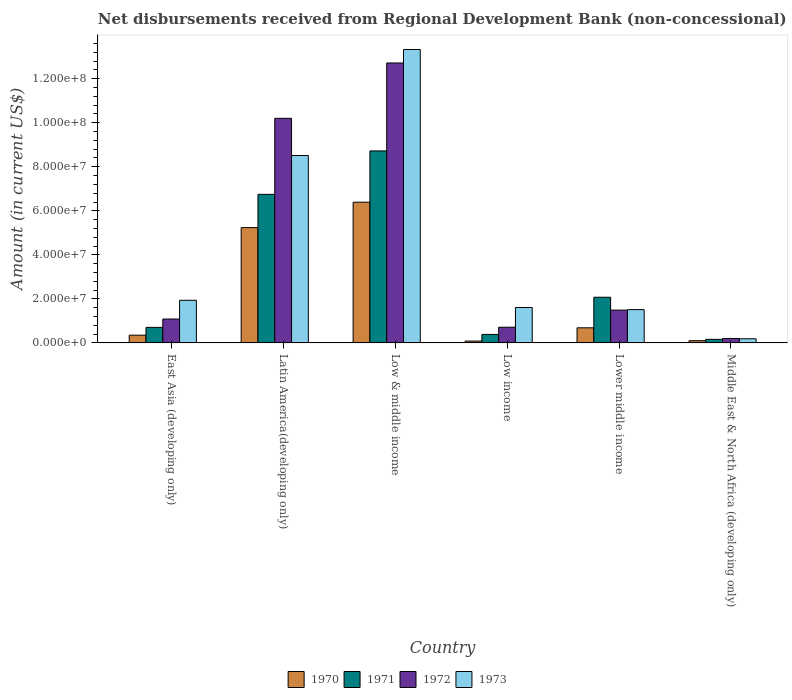How many groups of bars are there?
Your answer should be compact. 6. Are the number of bars per tick equal to the number of legend labels?
Provide a succinct answer. Yes. Are the number of bars on each tick of the X-axis equal?
Keep it short and to the point. Yes. How many bars are there on the 6th tick from the left?
Keep it short and to the point. 4. How many bars are there on the 1st tick from the right?
Give a very brief answer. 4. What is the label of the 1st group of bars from the left?
Provide a succinct answer. East Asia (developing only). What is the amount of disbursements received from Regional Development Bank in 1970 in East Asia (developing only)?
Provide a short and direct response. 3.53e+06. Across all countries, what is the maximum amount of disbursements received from Regional Development Bank in 1972?
Give a very brief answer. 1.27e+08. Across all countries, what is the minimum amount of disbursements received from Regional Development Bank in 1970?
Keep it short and to the point. 8.50e+05. What is the total amount of disbursements received from Regional Development Bank in 1970 in the graph?
Your answer should be compact. 1.29e+08. What is the difference between the amount of disbursements received from Regional Development Bank in 1970 in Low & middle income and that in Lower middle income?
Provide a short and direct response. 5.70e+07. What is the difference between the amount of disbursements received from Regional Development Bank in 1970 in Low & middle income and the amount of disbursements received from Regional Development Bank in 1971 in East Asia (developing only)?
Provide a short and direct response. 5.68e+07. What is the average amount of disbursements received from Regional Development Bank in 1971 per country?
Your answer should be very brief. 3.13e+07. What is the difference between the amount of disbursements received from Regional Development Bank of/in 1972 and amount of disbursements received from Regional Development Bank of/in 1971 in East Asia (developing only)?
Keep it short and to the point. 3.80e+06. What is the ratio of the amount of disbursements received from Regional Development Bank in 1971 in Latin America(developing only) to that in Low & middle income?
Provide a succinct answer. 0.77. What is the difference between the highest and the second highest amount of disbursements received from Regional Development Bank in 1973?
Your answer should be compact. 1.14e+08. What is the difference between the highest and the lowest amount of disbursements received from Regional Development Bank in 1973?
Your answer should be very brief. 1.31e+08. Is the sum of the amount of disbursements received from Regional Development Bank in 1971 in Latin America(developing only) and Low & middle income greater than the maximum amount of disbursements received from Regional Development Bank in 1972 across all countries?
Provide a succinct answer. Yes. Is it the case that in every country, the sum of the amount of disbursements received from Regional Development Bank in 1971 and amount of disbursements received from Regional Development Bank in 1972 is greater than the sum of amount of disbursements received from Regional Development Bank in 1973 and amount of disbursements received from Regional Development Bank in 1970?
Provide a short and direct response. No. What does the 2nd bar from the right in Low & middle income represents?
Provide a short and direct response. 1972. Is it the case that in every country, the sum of the amount of disbursements received from Regional Development Bank in 1972 and amount of disbursements received from Regional Development Bank in 1971 is greater than the amount of disbursements received from Regional Development Bank in 1970?
Offer a terse response. Yes. Are all the bars in the graph horizontal?
Your response must be concise. No. What is the difference between two consecutive major ticks on the Y-axis?
Your answer should be compact. 2.00e+07. Does the graph contain any zero values?
Give a very brief answer. No. How many legend labels are there?
Offer a very short reply. 4. What is the title of the graph?
Ensure brevity in your answer.  Net disbursements received from Regional Development Bank (non-concessional). What is the label or title of the X-axis?
Your answer should be compact. Country. What is the label or title of the Y-axis?
Your answer should be compact. Amount (in current US$). What is the Amount (in current US$) of 1970 in East Asia (developing only)?
Offer a terse response. 3.53e+06. What is the Amount (in current US$) in 1971 in East Asia (developing only)?
Your response must be concise. 7.06e+06. What is the Amount (in current US$) of 1972 in East Asia (developing only)?
Provide a succinct answer. 1.09e+07. What is the Amount (in current US$) of 1973 in East Asia (developing only)?
Offer a terse response. 1.94e+07. What is the Amount (in current US$) of 1970 in Latin America(developing only)?
Offer a terse response. 5.24e+07. What is the Amount (in current US$) of 1971 in Latin America(developing only)?
Ensure brevity in your answer.  6.75e+07. What is the Amount (in current US$) in 1972 in Latin America(developing only)?
Make the answer very short. 1.02e+08. What is the Amount (in current US$) in 1973 in Latin America(developing only)?
Provide a succinct answer. 8.51e+07. What is the Amount (in current US$) in 1970 in Low & middle income?
Keep it short and to the point. 6.39e+07. What is the Amount (in current US$) in 1971 in Low & middle income?
Your answer should be compact. 8.72e+07. What is the Amount (in current US$) in 1972 in Low & middle income?
Offer a terse response. 1.27e+08. What is the Amount (in current US$) of 1973 in Low & middle income?
Offer a very short reply. 1.33e+08. What is the Amount (in current US$) of 1970 in Low income?
Provide a succinct answer. 8.50e+05. What is the Amount (in current US$) in 1971 in Low income?
Your response must be concise. 3.88e+06. What is the Amount (in current US$) in 1972 in Low income?
Offer a terse response. 7.14e+06. What is the Amount (in current US$) of 1973 in Low income?
Your answer should be very brief. 1.61e+07. What is the Amount (in current US$) in 1970 in Lower middle income?
Offer a very short reply. 6.87e+06. What is the Amount (in current US$) in 1971 in Lower middle income?
Keep it short and to the point. 2.08e+07. What is the Amount (in current US$) of 1972 in Lower middle income?
Your answer should be compact. 1.49e+07. What is the Amount (in current US$) in 1973 in Lower middle income?
Your answer should be compact. 1.51e+07. What is the Amount (in current US$) in 1970 in Middle East & North Africa (developing only)?
Provide a succinct answer. 1.02e+06. What is the Amount (in current US$) of 1971 in Middle East & North Africa (developing only)?
Ensure brevity in your answer.  1.64e+06. What is the Amount (in current US$) in 1972 in Middle East & North Africa (developing only)?
Your response must be concise. 2.02e+06. What is the Amount (in current US$) of 1973 in Middle East & North Africa (developing only)?
Keep it short and to the point. 1.90e+06. Across all countries, what is the maximum Amount (in current US$) of 1970?
Provide a succinct answer. 6.39e+07. Across all countries, what is the maximum Amount (in current US$) in 1971?
Provide a short and direct response. 8.72e+07. Across all countries, what is the maximum Amount (in current US$) of 1972?
Offer a terse response. 1.27e+08. Across all countries, what is the maximum Amount (in current US$) in 1973?
Offer a terse response. 1.33e+08. Across all countries, what is the minimum Amount (in current US$) in 1970?
Give a very brief answer. 8.50e+05. Across all countries, what is the minimum Amount (in current US$) of 1971?
Provide a short and direct response. 1.64e+06. Across all countries, what is the minimum Amount (in current US$) of 1972?
Make the answer very short. 2.02e+06. Across all countries, what is the minimum Amount (in current US$) in 1973?
Make the answer very short. 1.90e+06. What is the total Amount (in current US$) of 1970 in the graph?
Offer a terse response. 1.29e+08. What is the total Amount (in current US$) in 1971 in the graph?
Make the answer very short. 1.88e+08. What is the total Amount (in current US$) in 1972 in the graph?
Your answer should be very brief. 2.64e+08. What is the total Amount (in current US$) in 1973 in the graph?
Ensure brevity in your answer.  2.71e+08. What is the difference between the Amount (in current US$) in 1970 in East Asia (developing only) and that in Latin America(developing only)?
Give a very brief answer. -4.88e+07. What is the difference between the Amount (in current US$) of 1971 in East Asia (developing only) and that in Latin America(developing only)?
Your response must be concise. -6.04e+07. What is the difference between the Amount (in current US$) of 1972 in East Asia (developing only) and that in Latin America(developing only)?
Your answer should be compact. -9.11e+07. What is the difference between the Amount (in current US$) of 1973 in East Asia (developing only) and that in Latin America(developing only)?
Your answer should be very brief. -6.58e+07. What is the difference between the Amount (in current US$) of 1970 in East Asia (developing only) and that in Low & middle income?
Your answer should be very brief. -6.04e+07. What is the difference between the Amount (in current US$) in 1971 in East Asia (developing only) and that in Low & middle income?
Provide a short and direct response. -8.01e+07. What is the difference between the Amount (in current US$) in 1972 in East Asia (developing only) and that in Low & middle income?
Offer a terse response. -1.16e+08. What is the difference between the Amount (in current US$) in 1973 in East Asia (developing only) and that in Low & middle income?
Provide a short and direct response. -1.14e+08. What is the difference between the Amount (in current US$) in 1970 in East Asia (developing only) and that in Low income?
Offer a terse response. 2.68e+06. What is the difference between the Amount (in current US$) of 1971 in East Asia (developing only) and that in Low income?
Make the answer very short. 3.19e+06. What is the difference between the Amount (in current US$) of 1972 in East Asia (developing only) and that in Low income?
Offer a terse response. 3.72e+06. What is the difference between the Amount (in current US$) of 1973 in East Asia (developing only) and that in Low income?
Your answer should be compact. 3.28e+06. What is the difference between the Amount (in current US$) in 1970 in East Asia (developing only) and that in Lower middle income?
Your answer should be very brief. -3.34e+06. What is the difference between the Amount (in current US$) of 1971 in East Asia (developing only) and that in Lower middle income?
Make the answer very short. -1.37e+07. What is the difference between the Amount (in current US$) in 1972 in East Asia (developing only) and that in Lower middle income?
Your response must be concise. -4.04e+06. What is the difference between the Amount (in current US$) in 1973 in East Asia (developing only) and that in Lower middle income?
Provide a succinct answer. 4.23e+06. What is the difference between the Amount (in current US$) of 1970 in East Asia (developing only) and that in Middle East & North Africa (developing only)?
Provide a short and direct response. 2.51e+06. What is the difference between the Amount (in current US$) in 1971 in East Asia (developing only) and that in Middle East & North Africa (developing only)?
Keep it short and to the point. 5.43e+06. What is the difference between the Amount (in current US$) of 1972 in East Asia (developing only) and that in Middle East & North Africa (developing only)?
Provide a short and direct response. 8.83e+06. What is the difference between the Amount (in current US$) of 1973 in East Asia (developing only) and that in Middle East & North Africa (developing only)?
Offer a very short reply. 1.75e+07. What is the difference between the Amount (in current US$) in 1970 in Latin America(developing only) and that in Low & middle income?
Offer a very short reply. -1.15e+07. What is the difference between the Amount (in current US$) of 1971 in Latin America(developing only) and that in Low & middle income?
Your answer should be compact. -1.97e+07. What is the difference between the Amount (in current US$) of 1972 in Latin America(developing only) and that in Low & middle income?
Keep it short and to the point. -2.51e+07. What is the difference between the Amount (in current US$) in 1973 in Latin America(developing only) and that in Low & middle income?
Make the answer very short. -4.81e+07. What is the difference between the Amount (in current US$) in 1970 in Latin America(developing only) and that in Low income?
Provide a short and direct response. 5.15e+07. What is the difference between the Amount (in current US$) of 1971 in Latin America(developing only) and that in Low income?
Make the answer very short. 6.36e+07. What is the difference between the Amount (in current US$) of 1972 in Latin America(developing only) and that in Low income?
Provide a short and direct response. 9.49e+07. What is the difference between the Amount (in current US$) of 1973 in Latin America(developing only) and that in Low income?
Your answer should be compact. 6.90e+07. What is the difference between the Amount (in current US$) of 1970 in Latin America(developing only) and that in Lower middle income?
Keep it short and to the point. 4.55e+07. What is the difference between the Amount (in current US$) in 1971 in Latin America(developing only) and that in Lower middle income?
Give a very brief answer. 4.67e+07. What is the difference between the Amount (in current US$) in 1972 in Latin America(developing only) and that in Lower middle income?
Offer a terse response. 8.71e+07. What is the difference between the Amount (in current US$) of 1973 in Latin America(developing only) and that in Lower middle income?
Offer a very short reply. 7.00e+07. What is the difference between the Amount (in current US$) in 1970 in Latin America(developing only) and that in Middle East & North Africa (developing only)?
Provide a succinct answer. 5.14e+07. What is the difference between the Amount (in current US$) of 1971 in Latin America(developing only) and that in Middle East & North Africa (developing only)?
Your answer should be very brief. 6.58e+07. What is the difference between the Amount (in current US$) of 1972 in Latin America(developing only) and that in Middle East & North Africa (developing only)?
Your response must be concise. 1.00e+08. What is the difference between the Amount (in current US$) of 1973 in Latin America(developing only) and that in Middle East & North Africa (developing only)?
Make the answer very short. 8.32e+07. What is the difference between the Amount (in current US$) of 1970 in Low & middle income and that in Low income?
Your response must be concise. 6.31e+07. What is the difference between the Amount (in current US$) of 1971 in Low & middle income and that in Low income?
Provide a succinct answer. 8.33e+07. What is the difference between the Amount (in current US$) of 1972 in Low & middle income and that in Low income?
Give a very brief answer. 1.20e+08. What is the difference between the Amount (in current US$) in 1973 in Low & middle income and that in Low income?
Your answer should be compact. 1.17e+08. What is the difference between the Amount (in current US$) of 1970 in Low & middle income and that in Lower middle income?
Your answer should be very brief. 5.70e+07. What is the difference between the Amount (in current US$) of 1971 in Low & middle income and that in Lower middle income?
Give a very brief answer. 6.64e+07. What is the difference between the Amount (in current US$) of 1972 in Low & middle income and that in Lower middle income?
Ensure brevity in your answer.  1.12e+08. What is the difference between the Amount (in current US$) in 1973 in Low & middle income and that in Lower middle income?
Provide a short and direct response. 1.18e+08. What is the difference between the Amount (in current US$) in 1970 in Low & middle income and that in Middle East & North Africa (developing only)?
Ensure brevity in your answer.  6.29e+07. What is the difference between the Amount (in current US$) of 1971 in Low & middle income and that in Middle East & North Africa (developing only)?
Keep it short and to the point. 8.56e+07. What is the difference between the Amount (in current US$) in 1972 in Low & middle income and that in Middle East & North Africa (developing only)?
Provide a succinct answer. 1.25e+08. What is the difference between the Amount (in current US$) of 1973 in Low & middle income and that in Middle East & North Africa (developing only)?
Keep it short and to the point. 1.31e+08. What is the difference between the Amount (in current US$) in 1970 in Low income and that in Lower middle income?
Provide a short and direct response. -6.02e+06. What is the difference between the Amount (in current US$) of 1971 in Low income and that in Lower middle income?
Provide a succinct answer. -1.69e+07. What is the difference between the Amount (in current US$) in 1972 in Low income and that in Lower middle income?
Offer a very short reply. -7.76e+06. What is the difference between the Amount (in current US$) in 1973 in Low income and that in Lower middle income?
Offer a very short reply. 9.55e+05. What is the difference between the Amount (in current US$) in 1970 in Low income and that in Middle East & North Africa (developing only)?
Your answer should be very brief. -1.71e+05. What is the difference between the Amount (in current US$) in 1971 in Low income and that in Middle East & North Africa (developing only)?
Offer a terse response. 2.24e+06. What is the difference between the Amount (in current US$) of 1972 in Low income and that in Middle East & North Africa (developing only)?
Your response must be concise. 5.11e+06. What is the difference between the Amount (in current US$) in 1973 in Low income and that in Middle East & North Africa (developing only)?
Provide a short and direct response. 1.42e+07. What is the difference between the Amount (in current US$) of 1970 in Lower middle income and that in Middle East & North Africa (developing only)?
Provide a short and direct response. 5.85e+06. What is the difference between the Amount (in current US$) of 1971 in Lower middle income and that in Middle East & North Africa (developing only)?
Provide a short and direct response. 1.91e+07. What is the difference between the Amount (in current US$) in 1972 in Lower middle income and that in Middle East & North Africa (developing only)?
Ensure brevity in your answer.  1.29e+07. What is the difference between the Amount (in current US$) of 1973 in Lower middle income and that in Middle East & North Africa (developing only)?
Offer a very short reply. 1.32e+07. What is the difference between the Amount (in current US$) of 1970 in East Asia (developing only) and the Amount (in current US$) of 1971 in Latin America(developing only)?
Keep it short and to the point. -6.39e+07. What is the difference between the Amount (in current US$) in 1970 in East Asia (developing only) and the Amount (in current US$) in 1972 in Latin America(developing only)?
Ensure brevity in your answer.  -9.85e+07. What is the difference between the Amount (in current US$) in 1970 in East Asia (developing only) and the Amount (in current US$) in 1973 in Latin America(developing only)?
Keep it short and to the point. -8.16e+07. What is the difference between the Amount (in current US$) of 1971 in East Asia (developing only) and the Amount (in current US$) of 1972 in Latin America(developing only)?
Give a very brief answer. -9.49e+07. What is the difference between the Amount (in current US$) of 1971 in East Asia (developing only) and the Amount (in current US$) of 1973 in Latin America(developing only)?
Offer a terse response. -7.81e+07. What is the difference between the Amount (in current US$) in 1972 in East Asia (developing only) and the Amount (in current US$) in 1973 in Latin America(developing only)?
Offer a very short reply. -7.43e+07. What is the difference between the Amount (in current US$) in 1970 in East Asia (developing only) and the Amount (in current US$) in 1971 in Low & middle income?
Provide a succinct answer. -8.37e+07. What is the difference between the Amount (in current US$) of 1970 in East Asia (developing only) and the Amount (in current US$) of 1972 in Low & middle income?
Ensure brevity in your answer.  -1.24e+08. What is the difference between the Amount (in current US$) in 1970 in East Asia (developing only) and the Amount (in current US$) in 1973 in Low & middle income?
Keep it short and to the point. -1.30e+08. What is the difference between the Amount (in current US$) in 1971 in East Asia (developing only) and the Amount (in current US$) in 1972 in Low & middle income?
Provide a short and direct response. -1.20e+08. What is the difference between the Amount (in current US$) of 1971 in East Asia (developing only) and the Amount (in current US$) of 1973 in Low & middle income?
Your answer should be compact. -1.26e+08. What is the difference between the Amount (in current US$) in 1972 in East Asia (developing only) and the Amount (in current US$) in 1973 in Low & middle income?
Offer a terse response. -1.22e+08. What is the difference between the Amount (in current US$) of 1970 in East Asia (developing only) and the Amount (in current US$) of 1971 in Low income?
Provide a short and direct response. -3.48e+05. What is the difference between the Amount (in current US$) of 1970 in East Asia (developing only) and the Amount (in current US$) of 1972 in Low income?
Provide a succinct answer. -3.61e+06. What is the difference between the Amount (in current US$) in 1970 in East Asia (developing only) and the Amount (in current US$) in 1973 in Low income?
Your answer should be compact. -1.26e+07. What is the difference between the Amount (in current US$) of 1971 in East Asia (developing only) and the Amount (in current US$) of 1972 in Low income?
Your answer should be very brief. -7.50e+04. What is the difference between the Amount (in current US$) in 1971 in East Asia (developing only) and the Amount (in current US$) in 1973 in Low income?
Your answer should be very brief. -9.03e+06. What is the difference between the Amount (in current US$) in 1972 in East Asia (developing only) and the Amount (in current US$) in 1973 in Low income?
Offer a very short reply. -5.23e+06. What is the difference between the Amount (in current US$) of 1970 in East Asia (developing only) and the Amount (in current US$) of 1971 in Lower middle income?
Provide a short and direct response. -1.72e+07. What is the difference between the Amount (in current US$) in 1970 in East Asia (developing only) and the Amount (in current US$) in 1972 in Lower middle income?
Keep it short and to the point. -1.14e+07. What is the difference between the Amount (in current US$) in 1970 in East Asia (developing only) and the Amount (in current US$) in 1973 in Lower middle income?
Keep it short and to the point. -1.16e+07. What is the difference between the Amount (in current US$) of 1971 in East Asia (developing only) and the Amount (in current US$) of 1972 in Lower middle income?
Keep it short and to the point. -7.84e+06. What is the difference between the Amount (in current US$) of 1971 in East Asia (developing only) and the Amount (in current US$) of 1973 in Lower middle income?
Ensure brevity in your answer.  -8.07e+06. What is the difference between the Amount (in current US$) in 1972 in East Asia (developing only) and the Amount (in current US$) in 1973 in Lower middle income?
Your answer should be very brief. -4.28e+06. What is the difference between the Amount (in current US$) of 1970 in East Asia (developing only) and the Amount (in current US$) of 1971 in Middle East & North Africa (developing only)?
Your response must be concise. 1.89e+06. What is the difference between the Amount (in current US$) in 1970 in East Asia (developing only) and the Amount (in current US$) in 1972 in Middle East & North Africa (developing only)?
Provide a short and direct response. 1.50e+06. What is the difference between the Amount (in current US$) of 1970 in East Asia (developing only) and the Amount (in current US$) of 1973 in Middle East & North Africa (developing only)?
Your answer should be very brief. 1.63e+06. What is the difference between the Amount (in current US$) of 1971 in East Asia (developing only) and the Amount (in current US$) of 1972 in Middle East & North Africa (developing only)?
Your response must be concise. 5.04e+06. What is the difference between the Amount (in current US$) of 1971 in East Asia (developing only) and the Amount (in current US$) of 1973 in Middle East & North Africa (developing only)?
Offer a terse response. 5.17e+06. What is the difference between the Amount (in current US$) of 1972 in East Asia (developing only) and the Amount (in current US$) of 1973 in Middle East & North Africa (developing only)?
Ensure brevity in your answer.  8.96e+06. What is the difference between the Amount (in current US$) in 1970 in Latin America(developing only) and the Amount (in current US$) in 1971 in Low & middle income?
Provide a short and direct response. -3.48e+07. What is the difference between the Amount (in current US$) in 1970 in Latin America(developing only) and the Amount (in current US$) in 1972 in Low & middle income?
Provide a short and direct response. -7.48e+07. What is the difference between the Amount (in current US$) of 1970 in Latin America(developing only) and the Amount (in current US$) of 1973 in Low & middle income?
Provide a short and direct response. -8.09e+07. What is the difference between the Amount (in current US$) in 1971 in Latin America(developing only) and the Amount (in current US$) in 1972 in Low & middle income?
Ensure brevity in your answer.  -5.97e+07. What is the difference between the Amount (in current US$) of 1971 in Latin America(developing only) and the Amount (in current US$) of 1973 in Low & middle income?
Ensure brevity in your answer.  -6.58e+07. What is the difference between the Amount (in current US$) of 1972 in Latin America(developing only) and the Amount (in current US$) of 1973 in Low & middle income?
Your answer should be compact. -3.12e+07. What is the difference between the Amount (in current US$) of 1970 in Latin America(developing only) and the Amount (in current US$) of 1971 in Low income?
Provide a short and direct response. 4.85e+07. What is the difference between the Amount (in current US$) in 1970 in Latin America(developing only) and the Amount (in current US$) in 1972 in Low income?
Offer a terse response. 4.52e+07. What is the difference between the Amount (in current US$) of 1970 in Latin America(developing only) and the Amount (in current US$) of 1973 in Low income?
Offer a very short reply. 3.63e+07. What is the difference between the Amount (in current US$) in 1971 in Latin America(developing only) and the Amount (in current US$) in 1972 in Low income?
Give a very brief answer. 6.03e+07. What is the difference between the Amount (in current US$) in 1971 in Latin America(developing only) and the Amount (in current US$) in 1973 in Low income?
Keep it short and to the point. 5.14e+07. What is the difference between the Amount (in current US$) in 1972 in Latin America(developing only) and the Amount (in current US$) in 1973 in Low income?
Offer a very short reply. 8.59e+07. What is the difference between the Amount (in current US$) in 1970 in Latin America(developing only) and the Amount (in current US$) in 1971 in Lower middle income?
Provide a short and direct response. 3.16e+07. What is the difference between the Amount (in current US$) of 1970 in Latin America(developing only) and the Amount (in current US$) of 1972 in Lower middle income?
Your answer should be very brief. 3.75e+07. What is the difference between the Amount (in current US$) of 1970 in Latin America(developing only) and the Amount (in current US$) of 1973 in Lower middle income?
Give a very brief answer. 3.72e+07. What is the difference between the Amount (in current US$) of 1971 in Latin America(developing only) and the Amount (in current US$) of 1972 in Lower middle income?
Give a very brief answer. 5.26e+07. What is the difference between the Amount (in current US$) of 1971 in Latin America(developing only) and the Amount (in current US$) of 1973 in Lower middle income?
Offer a terse response. 5.23e+07. What is the difference between the Amount (in current US$) of 1972 in Latin America(developing only) and the Amount (in current US$) of 1973 in Lower middle income?
Keep it short and to the point. 8.69e+07. What is the difference between the Amount (in current US$) in 1970 in Latin America(developing only) and the Amount (in current US$) in 1971 in Middle East & North Africa (developing only)?
Make the answer very short. 5.07e+07. What is the difference between the Amount (in current US$) of 1970 in Latin America(developing only) and the Amount (in current US$) of 1972 in Middle East & North Africa (developing only)?
Provide a short and direct response. 5.04e+07. What is the difference between the Amount (in current US$) in 1970 in Latin America(developing only) and the Amount (in current US$) in 1973 in Middle East & North Africa (developing only)?
Make the answer very short. 5.05e+07. What is the difference between the Amount (in current US$) in 1971 in Latin America(developing only) and the Amount (in current US$) in 1972 in Middle East & North Africa (developing only)?
Provide a succinct answer. 6.55e+07. What is the difference between the Amount (in current US$) of 1971 in Latin America(developing only) and the Amount (in current US$) of 1973 in Middle East & North Africa (developing only)?
Make the answer very short. 6.56e+07. What is the difference between the Amount (in current US$) in 1972 in Latin America(developing only) and the Amount (in current US$) in 1973 in Middle East & North Africa (developing only)?
Make the answer very short. 1.00e+08. What is the difference between the Amount (in current US$) of 1970 in Low & middle income and the Amount (in current US$) of 1971 in Low income?
Provide a succinct answer. 6.00e+07. What is the difference between the Amount (in current US$) of 1970 in Low & middle income and the Amount (in current US$) of 1972 in Low income?
Ensure brevity in your answer.  5.68e+07. What is the difference between the Amount (in current US$) in 1970 in Low & middle income and the Amount (in current US$) in 1973 in Low income?
Provide a succinct answer. 4.78e+07. What is the difference between the Amount (in current US$) of 1971 in Low & middle income and the Amount (in current US$) of 1972 in Low income?
Offer a very short reply. 8.01e+07. What is the difference between the Amount (in current US$) of 1971 in Low & middle income and the Amount (in current US$) of 1973 in Low income?
Give a very brief answer. 7.11e+07. What is the difference between the Amount (in current US$) of 1972 in Low & middle income and the Amount (in current US$) of 1973 in Low income?
Offer a terse response. 1.11e+08. What is the difference between the Amount (in current US$) of 1970 in Low & middle income and the Amount (in current US$) of 1971 in Lower middle income?
Your response must be concise. 4.32e+07. What is the difference between the Amount (in current US$) of 1970 in Low & middle income and the Amount (in current US$) of 1972 in Lower middle income?
Keep it short and to the point. 4.90e+07. What is the difference between the Amount (in current US$) in 1970 in Low & middle income and the Amount (in current US$) in 1973 in Lower middle income?
Provide a short and direct response. 4.88e+07. What is the difference between the Amount (in current US$) of 1971 in Low & middle income and the Amount (in current US$) of 1972 in Lower middle income?
Your answer should be very brief. 7.23e+07. What is the difference between the Amount (in current US$) of 1971 in Low & middle income and the Amount (in current US$) of 1973 in Lower middle income?
Ensure brevity in your answer.  7.21e+07. What is the difference between the Amount (in current US$) in 1972 in Low & middle income and the Amount (in current US$) in 1973 in Lower middle income?
Give a very brief answer. 1.12e+08. What is the difference between the Amount (in current US$) in 1970 in Low & middle income and the Amount (in current US$) in 1971 in Middle East & North Africa (developing only)?
Your response must be concise. 6.23e+07. What is the difference between the Amount (in current US$) of 1970 in Low & middle income and the Amount (in current US$) of 1972 in Middle East & North Africa (developing only)?
Your response must be concise. 6.19e+07. What is the difference between the Amount (in current US$) of 1970 in Low & middle income and the Amount (in current US$) of 1973 in Middle East & North Africa (developing only)?
Provide a succinct answer. 6.20e+07. What is the difference between the Amount (in current US$) in 1971 in Low & middle income and the Amount (in current US$) in 1972 in Middle East & North Africa (developing only)?
Ensure brevity in your answer.  8.52e+07. What is the difference between the Amount (in current US$) in 1971 in Low & middle income and the Amount (in current US$) in 1973 in Middle East & North Africa (developing only)?
Give a very brief answer. 8.53e+07. What is the difference between the Amount (in current US$) in 1972 in Low & middle income and the Amount (in current US$) in 1973 in Middle East & North Africa (developing only)?
Your response must be concise. 1.25e+08. What is the difference between the Amount (in current US$) in 1970 in Low income and the Amount (in current US$) in 1971 in Lower middle income?
Keep it short and to the point. -1.99e+07. What is the difference between the Amount (in current US$) of 1970 in Low income and the Amount (in current US$) of 1972 in Lower middle income?
Give a very brief answer. -1.40e+07. What is the difference between the Amount (in current US$) of 1970 in Low income and the Amount (in current US$) of 1973 in Lower middle income?
Make the answer very short. -1.43e+07. What is the difference between the Amount (in current US$) of 1971 in Low income and the Amount (in current US$) of 1972 in Lower middle income?
Offer a terse response. -1.10e+07. What is the difference between the Amount (in current US$) in 1971 in Low income and the Amount (in current US$) in 1973 in Lower middle income?
Keep it short and to the point. -1.13e+07. What is the difference between the Amount (in current US$) of 1972 in Low income and the Amount (in current US$) of 1973 in Lower middle income?
Provide a succinct answer. -8.00e+06. What is the difference between the Amount (in current US$) in 1970 in Low income and the Amount (in current US$) in 1971 in Middle East & North Africa (developing only)?
Provide a succinct answer. -7.85e+05. What is the difference between the Amount (in current US$) in 1970 in Low income and the Amount (in current US$) in 1972 in Middle East & North Africa (developing only)?
Your answer should be compact. -1.17e+06. What is the difference between the Amount (in current US$) in 1970 in Low income and the Amount (in current US$) in 1973 in Middle East & North Africa (developing only)?
Your response must be concise. -1.05e+06. What is the difference between the Amount (in current US$) in 1971 in Low income and the Amount (in current US$) in 1972 in Middle East & North Africa (developing only)?
Your answer should be compact. 1.85e+06. What is the difference between the Amount (in current US$) in 1971 in Low income and the Amount (in current US$) in 1973 in Middle East & North Africa (developing only)?
Provide a short and direct response. 1.98e+06. What is the difference between the Amount (in current US$) in 1972 in Low income and the Amount (in current US$) in 1973 in Middle East & North Africa (developing only)?
Offer a very short reply. 5.24e+06. What is the difference between the Amount (in current US$) of 1970 in Lower middle income and the Amount (in current US$) of 1971 in Middle East & North Africa (developing only)?
Your answer should be very brief. 5.24e+06. What is the difference between the Amount (in current US$) of 1970 in Lower middle income and the Amount (in current US$) of 1972 in Middle East & North Africa (developing only)?
Offer a terse response. 4.85e+06. What is the difference between the Amount (in current US$) in 1970 in Lower middle income and the Amount (in current US$) in 1973 in Middle East & North Africa (developing only)?
Give a very brief answer. 4.98e+06. What is the difference between the Amount (in current US$) in 1971 in Lower middle income and the Amount (in current US$) in 1972 in Middle East & North Africa (developing only)?
Provide a succinct answer. 1.87e+07. What is the difference between the Amount (in current US$) of 1971 in Lower middle income and the Amount (in current US$) of 1973 in Middle East & North Africa (developing only)?
Offer a terse response. 1.89e+07. What is the difference between the Amount (in current US$) in 1972 in Lower middle income and the Amount (in current US$) in 1973 in Middle East & North Africa (developing only)?
Your answer should be very brief. 1.30e+07. What is the average Amount (in current US$) of 1970 per country?
Your answer should be compact. 2.14e+07. What is the average Amount (in current US$) in 1971 per country?
Your response must be concise. 3.13e+07. What is the average Amount (in current US$) in 1972 per country?
Your response must be concise. 4.40e+07. What is the average Amount (in current US$) in 1973 per country?
Provide a succinct answer. 4.51e+07. What is the difference between the Amount (in current US$) in 1970 and Amount (in current US$) in 1971 in East Asia (developing only)?
Make the answer very short. -3.54e+06. What is the difference between the Amount (in current US$) of 1970 and Amount (in current US$) of 1972 in East Asia (developing only)?
Your answer should be very brief. -7.33e+06. What is the difference between the Amount (in current US$) of 1970 and Amount (in current US$) of 1973 in East Asia (developing only)?
Provide a succinct answer. -1.58e+07. What is the difference between the Amount (in current US$) in 1971 and Amount (in current US$) in 1972 in East Asia (developing only)?
Make the answer very short. -3.80e+06. What is the difference between the Amount (in current US$) in 1971 and Amount (in current US$) in 1973 in East Asia (developing only)?
Your response must be concise. -1.23e+07. What is the difference between the Amount (in current US$) of 1972 and Amount (in current US$) of 1973 in East Asia (developing only)?
Provide a succinct answer. -8.51e+06. What is the difference between the Amount (in current US$) of 1970 and Amount (in current US$) of 1971 in Latin America(developing only)?
Keep it short and to the point. -1.51e+07. What is the difference between the Amount (in current US$) of 1970 and Amount (in current US$) of 1972 in Latin America(developing only)?
Give a very brief answer. -4.96e+07. What is the difference between the Amount (in current US$) of 1970 and Amount (in current US$) of 1973 in Latin America(developing only)?
Provide a succinct answer. -3.27e+07. What is the difference between the Amount (in current US$) in 1971 and Amount (in current US$) in 1972 in Latin America(developing only)?
Make the answer very short. -3.45e+07. What is the difference between the Amount (in current US$) in 1971 and Amount (in current US$) in 1973 in Latin America(developing only)?
Offer a very short reply. -1.76e+07. What is the difference between the Amount (in current US$) of 1972 and Amount (in current US$) of 1973 in Latin America(developing only)?
Offer a terse response. 1.69e+07. What is the difference between the Amount (in current US$) in 1970 and Amount (in current US$) in 1971 in Low & middle income?
Your answer should be very brief. -2.33e+07. What is the difference between the Amount (in current US$) in 1970 and Amount (in current US$) in 1972 in Low & middle income?
Your answer should be very brief. -6.32e+07. What is the difference between the Amount (in current US$) in 1970 and Amount (in current US$) in 1973 in Low & middle income?
Offer a terse response. -6.93e+07. What is the difference between the Amount (in current US$) of 1971 and Amount (in current US$) of 1972 in Low & middle income?
Offer a terse response. -3.99e+07. What is the difference between the Amount (in current US$) of 1971 and Amount (in current US$) of 1973 in Low & middle income?
Keep it short and to the point. -4.60e+07. What is the difference between the Amount (in current US$) of 1972 and Amount (in current US$) of 1973 in Low & middle income?
Offer a terse response. -6.10e+06. What is the difference between the Amount (in current US$) in 1970 and Amount (in current US$) in 1971 in Low income?
Keep it short and to the point. -3.02e+06. What is the difference between the Amount (in current US$) in 1970 and Amount (in current US$) in 1972 in Low income?
Your response must be concise. -6.29e+06. What is the difference between the Amount (in current US$) of 1970 and Amount (in current US$) of 1973 in Low income?
Your response must be concise. -1.52e+07. What is the difference between the Amount (in current US$) of 1971 and Amount (in current US$) of 1972 in Low income?
Keep it short and to the point. -3.26e+06. What is the difference between the Amount (in current US$) of 1971 and Amount (in current US$) of 1973 in Low income?
Your answer should be compact. -1.22e+07. What is the difference between the Amount (in current US$) of 1972 and Amount (in current US$) of 1973 in Low income?
Your answer should be very brief. -8.95e+06. What is the difference between the Amount (in current US$) of 1970 and Amount (in current US$) of 1971 in Lower middle income?
Make the answer very short. -1.39e+07. What is the difference between the Amount (in current US$) of 1970 and Amount (in current US$) of 1972 in Lower middle income?
Keep it short and to the point. -8.03e+06. What is the difference between the Amount (in current US$) of 1970 and Amount (in current US$) of 1973 in Lower middle income?
Give a very brief answer. -8.26e+06. What is the difference between the Amount (in current US$) in 1971 and Amount (in current US$) in 1972 in Lower middle income?
Make the answer very short. 5.85e+06. What is the difference between the Amount (in current US$) in 1971 and Amount (in current US$) in 1973 in Lower middle income?
Offer a very short reply. 5.62e+06. What is the difference between the Amount (in current US$) in 1972 and Amount (in current US$) in 1973 in Lower middle income?
Keep it short and to the point. -2.36e+05. What is the difference between the Amount (in current US$) of 1970 and Amount (in current US$) of 1971 in Middle East & North Africa (developing only)?
Your response must be concise. -6.14e+05. What is the difference between the Amount (in current US$) in 1970 and Amount (in current US$) in 1972 in Middle East & North Africa (developing only)?
Provide a succinct answer. -1.00e+06. What is the difference between the Amount (in current US$) in 1970 and Amount (in current US$) in 1973 in Middle East & North Africa (developing only)?
Provide a succinct answer. -8.75e+05. What is the difference between the Amount (in current US$) of 1971 and Amount (in current US$) of 1972 in Middle East & North Africa (developing only)?
Your response must be concise. -3.89e+05. What is the difference between the Amount (in current US$) in 1971 and Amount (in current US$) in 1973 in Middle East & North Africa (developing only)?
Give a very brief answer. -2.61e+05. What is the difference between the Amount (in current US$) in 1972 and Amount (in current US$) in 1973 in Middle East & North Africa (developing only)?
Ensure brevity in your answer.  1.28e+05. What is the ratio of the Amount (in current US$) of 1970 in East Asia (developing only) to that in Latin America(developing only)?
Offer a very short reply. 0.07. What is the ratio of the Amount (in current US$) in 1971 in East Asia (developing only) to that in Latin America(developing only)?
Offer a terse response. 0.1. What is the ratio of the Amount (in current US$) in 1972 in East Asia (developing only) to that in Latin America(developing only)?
Your response must be concise. 0.11. What is the ratio of the Amount (in current US$) in 1973 in East Asia (developing only) to that in Latin America(developing only)?
Your response must be concise. 0.23. What is the ratio of the Amount (in current US$) in 1970 in East Asia (developing only) to that in Low & middle income?
Give a very brief answer. 0.06. What is the ratio of the Amount (in current US$) of 1971 in East Asia (developing only) to that in Low & middle income?
Ensure brevity in your answer.  0.08. What is the ratio of the Amount (in current US$) in 1972 in East Asia (developing only) to that in Low & middle income?
Keep it short and to the point. 0.09. What is the ratio of the Amount (in current US$) of 1973 in East Asia (developing only) to that in Low & middle income?
Offer a very short reply. 0.15. What is the ratio of the Amount (in current US$) in 1970 in East Asia (developing only) to that in Low income?
Provide a succinct answer. 4.15. What is the ratio of the Amount (in current US$) of 1971 in East Asia (developing only) to that in Low income?
Keep it short and to the point. 1.82. What is the ratio of the Amount (in current US$) of 1972 in East Asia (developing only) to that in Low income?
Your response must be concise. 1.52. What is the ratio of the Amount (in current US$) of 1973 in East Asia (developing only) to that in Low income?
Your answer should be very brief. 1.2. What is the ratio of the Amount (in current US$) in 1970 in East Asia (developing only) to that in Lower middle income?
Offer a terse response. 0.51. What is the ratio of the Amount (in current US$) in 1971 in East Asia (developing only) to that in Lower middle income?
Make the answer very short. 0.34. What is the ratio of the Amount (in current US$) in 1972 in East Asia (developing only) to that in Lower middle income?
Offer a very short reply. 0.73. What is the ratio of the Amount (in current US$) in 1973 in East Asia (developing only) to that in Lower middle income?
Keep it short and to the point. 1.28. What is the ratio of the Amount (in current US$) of 1970 in East Asia (developing only) to that in Middle East & North Africa (developing only)?
Ensure brevity in your answer.  3.45. What is the ratio of the Amount (in current US$) in 1971 in East Asia (developing only) to that in Middle East & North Africa (developing only)?
Make the answer very short. 4.32. What is the ratio of the Amount (in current US$) of 1972 in East Asia (developing only) to that in Middle East & North Africa (developing only)?
Offer a terse response. 5.36. What is the ratio of the Amount (in current US$) of 1973 in East Asia (developing only) to that in Middle East & North Africa (developing only)?
Offer a terse response. 10.21. What is the ratio of the Amount (in current US$) in 1970 in Latin America(developing only) to that in Low & middle income?
Provide a succinct answer. 0.82. What is the ratio of the Amount (in current US$) of 1971 in Latin America(developing only) to that in Low & middle income?
Provide a short and direct response. 0.77. What is the ratio of the Amount (in current US$) in 1972 in Latin America(developing only) to that in Low & middle income?
Provide a succinct answer. 0.8. What is the ratio of the Amount (in current US$) of 1973 in Latin America(developing only) to that in Low & middle income?
Give a very brief answer. 0.64. What is the ratio of the Amount (in current US$) of 1970 in Latin America(developing only) to that in Low income?
Your answer should be very brief. 61.62. What is the ratio of the Amount (in current US$) of 1971 in Latin America(developing only) to that in Low income?
Make the answer very short. 17.41. What is the ratio of the Amount (in current US$) in 1972 in Latin America(developing only) to that in Low income?
Offer a very short reply. 14.29. What is the ratio of the Amount (in current US$) in 1973 in Latin America(developing only) to that in Low income?
Your answer should be compact. 5.29. What is the ratio of the Amount (in current US$) in 1970 in Latin America(developing only) to that in Lower middle income?
Provide a short and direct response. 7.62. What is the ratio of the Amount (in current US$) in 1971 in Latin America(developing only) to that in Lower middle income?
Provide a short and direct response. 3.25. What is the ratio of the Amount (in current US$) in 1972 in Latin America(developing only) to that in Lower middle income?
Your answer should be compact. 6.85. What is the ratio of the Amount (in current US$) of 1973 in Latin America(developing only) to that in Lower middle income?
Provide a succinct answer. 5.62. What is the ratio of the Amount (in current US$) in 1970 in Latin America(developing only) to that in Middle East & North Africa (developing only)?
Keep it short and to the point. 51.3. What is the ratio of the Amount (in current US$) in 1971 in Latin America(developing only) to that in Middle East & North Africa (developing only)?
Give a very brief answer. 41.27. What is the ratio of the Amount (in current US$) of 1972 in Latin America(developing only) to that in Middle East & North Africa (developing only)?
Offer a very short reply. 50.4. What is the ratio of the Amount (in current US$) of 1973 in Latin America(developing only) to that in Middle East & North Africa (developing only)?
Keep it short and to the point. 44.9. What is the ratio of the Amount (in current US$) in 1970 in Low & middle income to that in Low income?
Provide a succinct answer. 75.18. What is the ratio of the Amount (in current US$) in 1971 in Low & middle income to that in Low income?
Make the answer very short. 22.5. What is the ratio of the Amount (in current US$) in 1972 in Low & middle income to that in Low income?
Give a very brief answer. 17.81. What is the ratio of the Amount (in current US$) of 1973 in Low & middle income to that in Low income?
Keep it short and to the point. 8.28. What is the ratio of the Amount (in current US$) in 1970 in Low & middle income to that in Lower middle income?
Provide a succinct answer. 9.3. What is the ratio of the Amount (in current US$) in 1971 in Low & middle income to that in Lower middle income?
Offer a terse response. 4.2. What is the ratio of the Amount (in current US$) of 1972 in Low & middle income to that in Lower middle income?
Your response must be concise. 8.53. What is the ratio of the Amount (in current US$) of 1973 in Low & middle income to that in Lower middle income?
Your answer should be compact. 8.8. What is the ratio of the Amount (in current US$) of 1970 in Low & middle income to that in Middle East & North Africa (developing only)?
Offer a terse response. 62.59. What is the ratio of the Amount (in current US$) in 1971 in Low & middle income to that in Middle East & North Africa (developing only)?
Provide a succinct answer. 53.33. What is the ratio of the Amount (in current US$) of 1972 in Low & middle income to that in Middle East & North Africa (developing only)?
Provide a succinct answer. 62.81. What is the ratio of the Amount (in current US$) in 1973 in Low & middle income to that in Middle East & North Africa (developing only)?
Provide a short and direct response. 70.27. What is the ratio of the Amount (in current US$) of 1970 in Low income to that in Lower middle income?
Your response must be concise. 0.12. What is the ratio of the Amount (in current US$) of 1971 in Low income to that in Lower middle income?
Your answer should be compact. 0.19. What is the ratio of the Amount (in current US$) in 1972 in Low income to that in Lower middle income?
Ensure brevity in your answer.  0.48. What is the ratio of the Amount (in current US$) in 1973 in Low income to that in Lower middle income?
Make the answer very short. 1.06. What is the ratio of the Amount (in current US$) of 1970 in Low income to that in Middle East & North Africa (developing only)?
Offer a very short reply. 0.83. What is the ratio of the Amount (in current US$) in 1971 in Low income to that in Middle East & North Africa (developing only)?
Provide a succinct answer. 2.37. What is the ratio of the Amount (in current US$) in 1972 in Low income to that in Middle East & North Africa (developing only)?
Ensure brevity in your answer.  3.53. What is the ratio of the Amount (in current US$) in 1973 in Low income to that in Middle East & North Africa (developing only)?
Ensure brevity in your answer.  8.49. What is the ratio of the Amount (in current US$) of 1970 in Lower middle income to that in Middle East & North Africa (developing only)?
Offer a terse response. 6.73. What is the ratio of the Amount (in current US$) in 1971 in Lower middle income to that in Middle East & North Africa (developing only)?
Offer a terse response. 12.69. What is the ratio of the Amount (in current US$) in 1972 in Lower middle income to that in Middle East & North Africa (developing only)?
Offer a very short reply. 7.36. What is the ratio of the Amount (in current US$) in 1973 in Lower middle income to that in Middle East & North Africa (developing only)?
Give a very brief answer. 7.98. What is the difference between the highest and the second highest Amount (in current US$) in 1970?
Provide a short and direct response. 1.15e+07. What is the difference between the highest and the second highest Amount (in current US$) of 1971?
Ensure brevity in your answer.  1.97e+07. What is the difference between the highest and the second highest Amount (in current US$) of 1972?
Keep it short and to the point. 2.51e+07. What is the difference between the highest and the second highest Amount (in current US$) of 1973?
Keep it short and to the point. 4.81e+07. What is the difference between the highest and the lowest Amount (in current US$) in 1970?
Keep it short and to the point. 6.31e+07. What is the difference between the highest and the lowest Amount (in current US$) in 1971?
Ensure brevity in your answer.  8.56e+07. What is the difference between the highest and the lowest Amount (in current US$) of 1972?
Make the answer very short. 1.25e+08. What is the difference between the highest and the lowest Amount (in current US$) in 1973?
Give a very brief answer. 1.31e+08. 